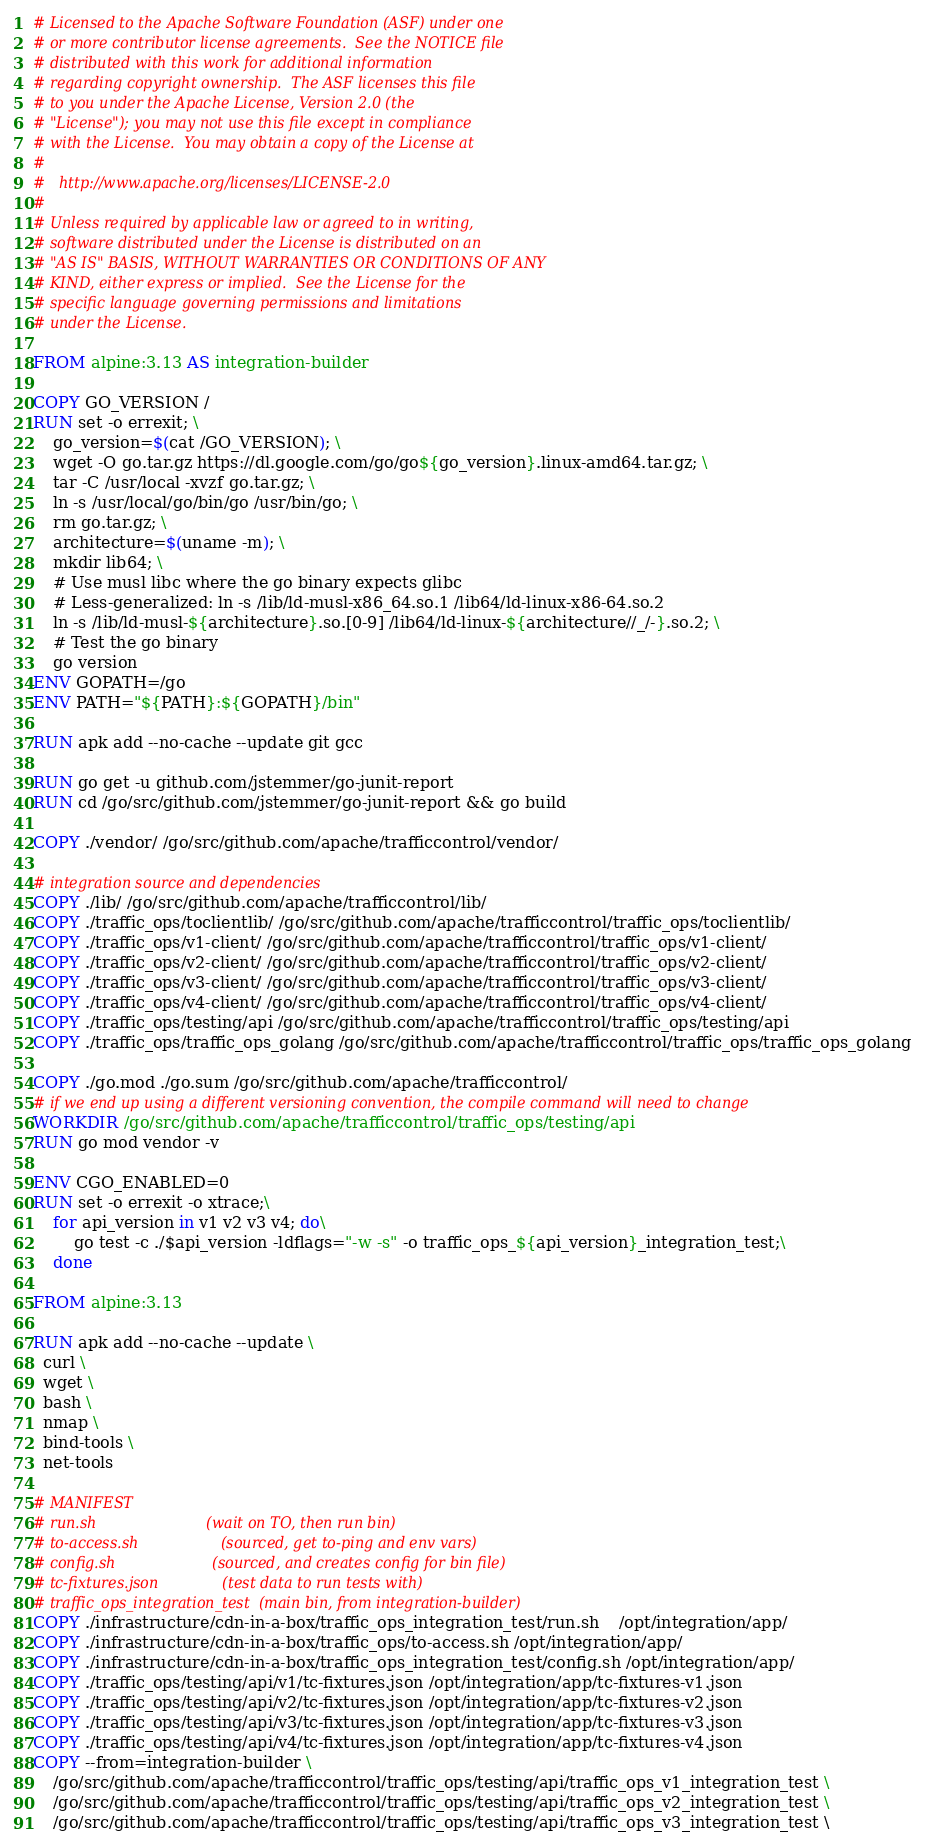Convert code to text. <code><loc_0><loc_0><loc_500><loc_500><_Dockerfile_># Licensed to the Apache Software Foundation (ASF) under one
# or more contributor license agreements.  See the NOTICE file
# distributed with this work for additional information
# regarding copyright ownership.  The ASF licenses this file
# to you under the Apache License, Version 2.0 (the
# "License"); you may not use this file except in compliance
# with the License.  You may obtain a copy of the License at
#
#   http://www.apache.org/licenses/LICENSE-2.0
#
# Unless required by applicable law or agreed to in writing,
# software distributed under the License is distributed on an
# "AS IS" BASIS, WITHOUT WARRANTIES OR CONDITIONS OF ANY
# KIND, either express or implied.  See the License for the
# specific language governing permissions and limitations
# under the License.

FROM alpine:3.13 AS integration-builder

COPY GO_VERSION /
RUN set -o errexit; \
    go_version=$(cat /GO_VERSION); \
    wget -O go.tar.gz https://dl.google.com/go/go${go_version}.linux-amd64.tar.gz; \
    tar -C /usr/local -xvzf go.tar.gz; \
    ln -s /usr/local/go/bin/go /usr/bin/go; \
    rm go.tar.gz; \
    architecture=$(uname -m); \
    mkdir lib64; \
    # Use musl libc where the go binary expects glibc
    # Less-generalized: ln -s /lib/ld-musl-x86_64.so.1 /lib64/ld-linux-x86-64.so.2
    ln -s /lib/ld-musl-${architecture}.so.[0-9] /lib64/ld-linux-${architecture//_/-}.so.2; \
    # Test the go binary
    go version
ENV GOPATH=/go
ENV PATH="${PATH}:${GOPATH}/bin"

RUN apk add --no-cache --update git gcc

RUN go get -u github.com/jstemmer/go-junit-report
RUN cd /go/src/github.com/jstemmer/go-junit-report && go build

COPY ./vendor/ /go/src/github.com/apache/trafficcontrol/vendor/

# integration source and dependencies
COPY ./lib/ /go/src/github.com/apache/trafficcontrol/lib/
COPY ./traffic_ops/toclientlib/ /go/src/github.com/apache/trafficcontrol/traffic_ops/toclientlib/
COPY ./traffic_ops/v1-client/ /go/src/github.com/apache/trafficcontrol/traffic_ops/v1-client/
COPY ./traffic_ops/v2-client/ /go/src/github.com/apache/trafficcontrol/traffic_ops/v2-client/
COPY ./traffic_ops/v3-client/ /go/src/github.com/apache/trafficcontrol/traffic_ops/v3-client/
COPY ./traffic_ops/v4-client/ /go/src/github.com/apache/trafficcontrol/traffic_ops/v4-client/
COPY ./traffic_ops/testing/api /go/src/github.com/apache/trafficcontrol/traffic_ops/testing/api
COPY ./traffic_ops/traffic_ops_golang /go/src/github.com/apache/trafficcontrol/traffic_ops/traffic_ops_golang

COPY ./go.mod ./go.sum /go/src/github.com/apache/trafficcontrol/
# if we end up using a different versioning convention, the compile command will need to change
WORKDIR /go/src/github.com/apache/trafficcontrol/traffic_ops/testing/api
RUN go mod vendor -v

ENV CGO_ENABLED=0
RUN set -o errexit -o xtrace;\
    for api_version in v1 v2 v3 v4; do\
        go test -c ./$api_version -ldflags="-w -s" -o traffic_ops_${api_version}_integration_test;\
    done

FROM alpine:3.13

RUN apk add --no-cache --update \
  curl \
  wget \
  bash \
  nmap \
  bind-tools \
  net-tools

# MANIFEST
# run.sh                        (wait on TO, then run bin)
# to-access.sh                  (sourced, get to-ping and env vars)
# config.sh                     (sourced, and creates config for bin file)
# tc-fixtures.json              (test data to run tests with)
# traffic_ops_integration_test  (main bin, from integration-builder)
COPY ./infrastructure/cdn-in-a-box/traffic_ops_integration_test/run.sh    /opt/integration/app/
COPY ./infrastructure/cdn-in-a-box/traffic_ops/to-access.sh /opt/integration/app/
COPY ./infrastructure/cdn-in-a-box/traffic_ops_integration_test/config.sh /opt/integration/app/
COPY ./traffic_ops/testing/api/v1/tc-fixtures.json /opt/integration/app/tc-fixtures-v1.json
COPY ./traffic_ops/testing/api/v2/tc-fixtures.json /opt/integration/app/tc-fixtures-v2.json
COPY ./traffic_ops/testing/api/v3/tc-fixtures.json /opt/integration/app/tc-fixtures-v3.json
COPY ./traffic_ops/testing/api/v4/tc-fixtures.json /opt/integration/app/tc-fixtures-v4.json
COPY --from=integration-builder \
    /go/src/github.com/apache/trafficcontrol/traffic_ops/testing/api/traffic_ops_v1_integration_test \
    /go/src/github.com/apache/trafficcontrol/traffic_ops/testing/api/traffic_ops_v2_integration_test \
    /go/src/github.com/apache/trafficcontrol/traffic_ops/testing/api/traffic_ops_v3_integration_test \</code> 